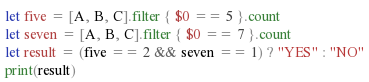<code> <loc_0><loc_0><loc_500><loc_500><_Swift_>let five = [A, B, C].filter { $0 == 5 }.count
let seven = [A, B, C].filter { $0 == 7 }.count
let result = (five == 2 && seven == 1) ? "YES" : "NO"
print(result)</code> 